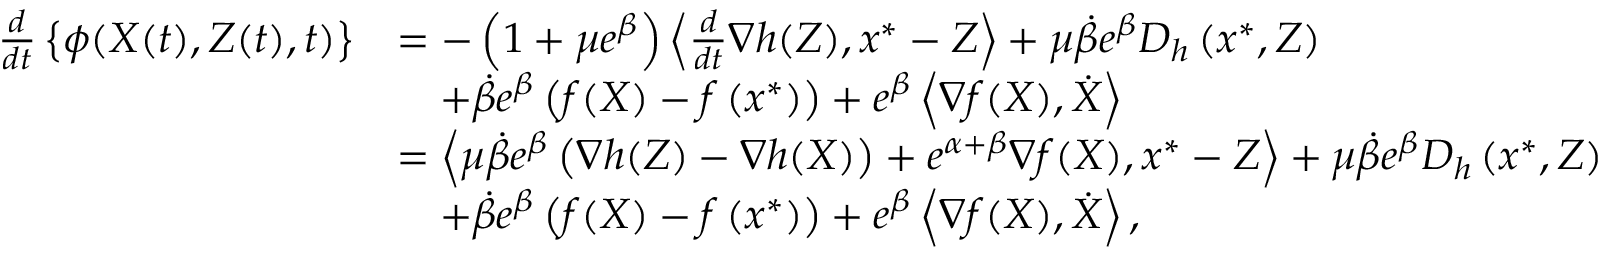Convert formula to latex. <formula><loc_0><loc_0><loc_500><loc_500>\begin{array} { r l } { \frac { d } { d t } \left \{ \phi ( X ( t ) , Z ( t ) , t ) \right \} } & { = - \left ( 1 + \mu e ^ { \beta } \right ) \left \langle \frac { d } { d t } \nabla h ( Z ) , x ^ { * } - Z \right \rangle + \mu \dot { \beta } e ^ { \beta } D _ { h } \left ( x ^ { * } , Z \right ) } \\ & { \quad + \dot { \beta } e ^ { \beta } \left ( f ( X ) - f \left ( x ^ { * } \right ) \right ) + e ^ { \beta } \left \langle \nabla f ( X ) , \dot { X } \right \rangle } \\ & { = \left \langle \mu \dot { \beta } e ^ { \beta } \left ( \nabla h ( Z ) - \nabla h ( X ) \right ) + e ^ { \alpha + \beta } \nabla f ( X ) , x ^ { * } - Z \right \rangle + \mu \dot { \beta } e ^ { \beta } D _ { h } \left ( x ^ { * } , Z \right ) } \\ & { \quad + \dot { \beta } e ^ { \beta } \left ( f ( X ) - f \left ( x ^ { * } \right ) \right ) + e ^ { \beta } \left \langle \nabla f ( X ) , \dot { X } \right \rangle , } \end{array}</formula> 